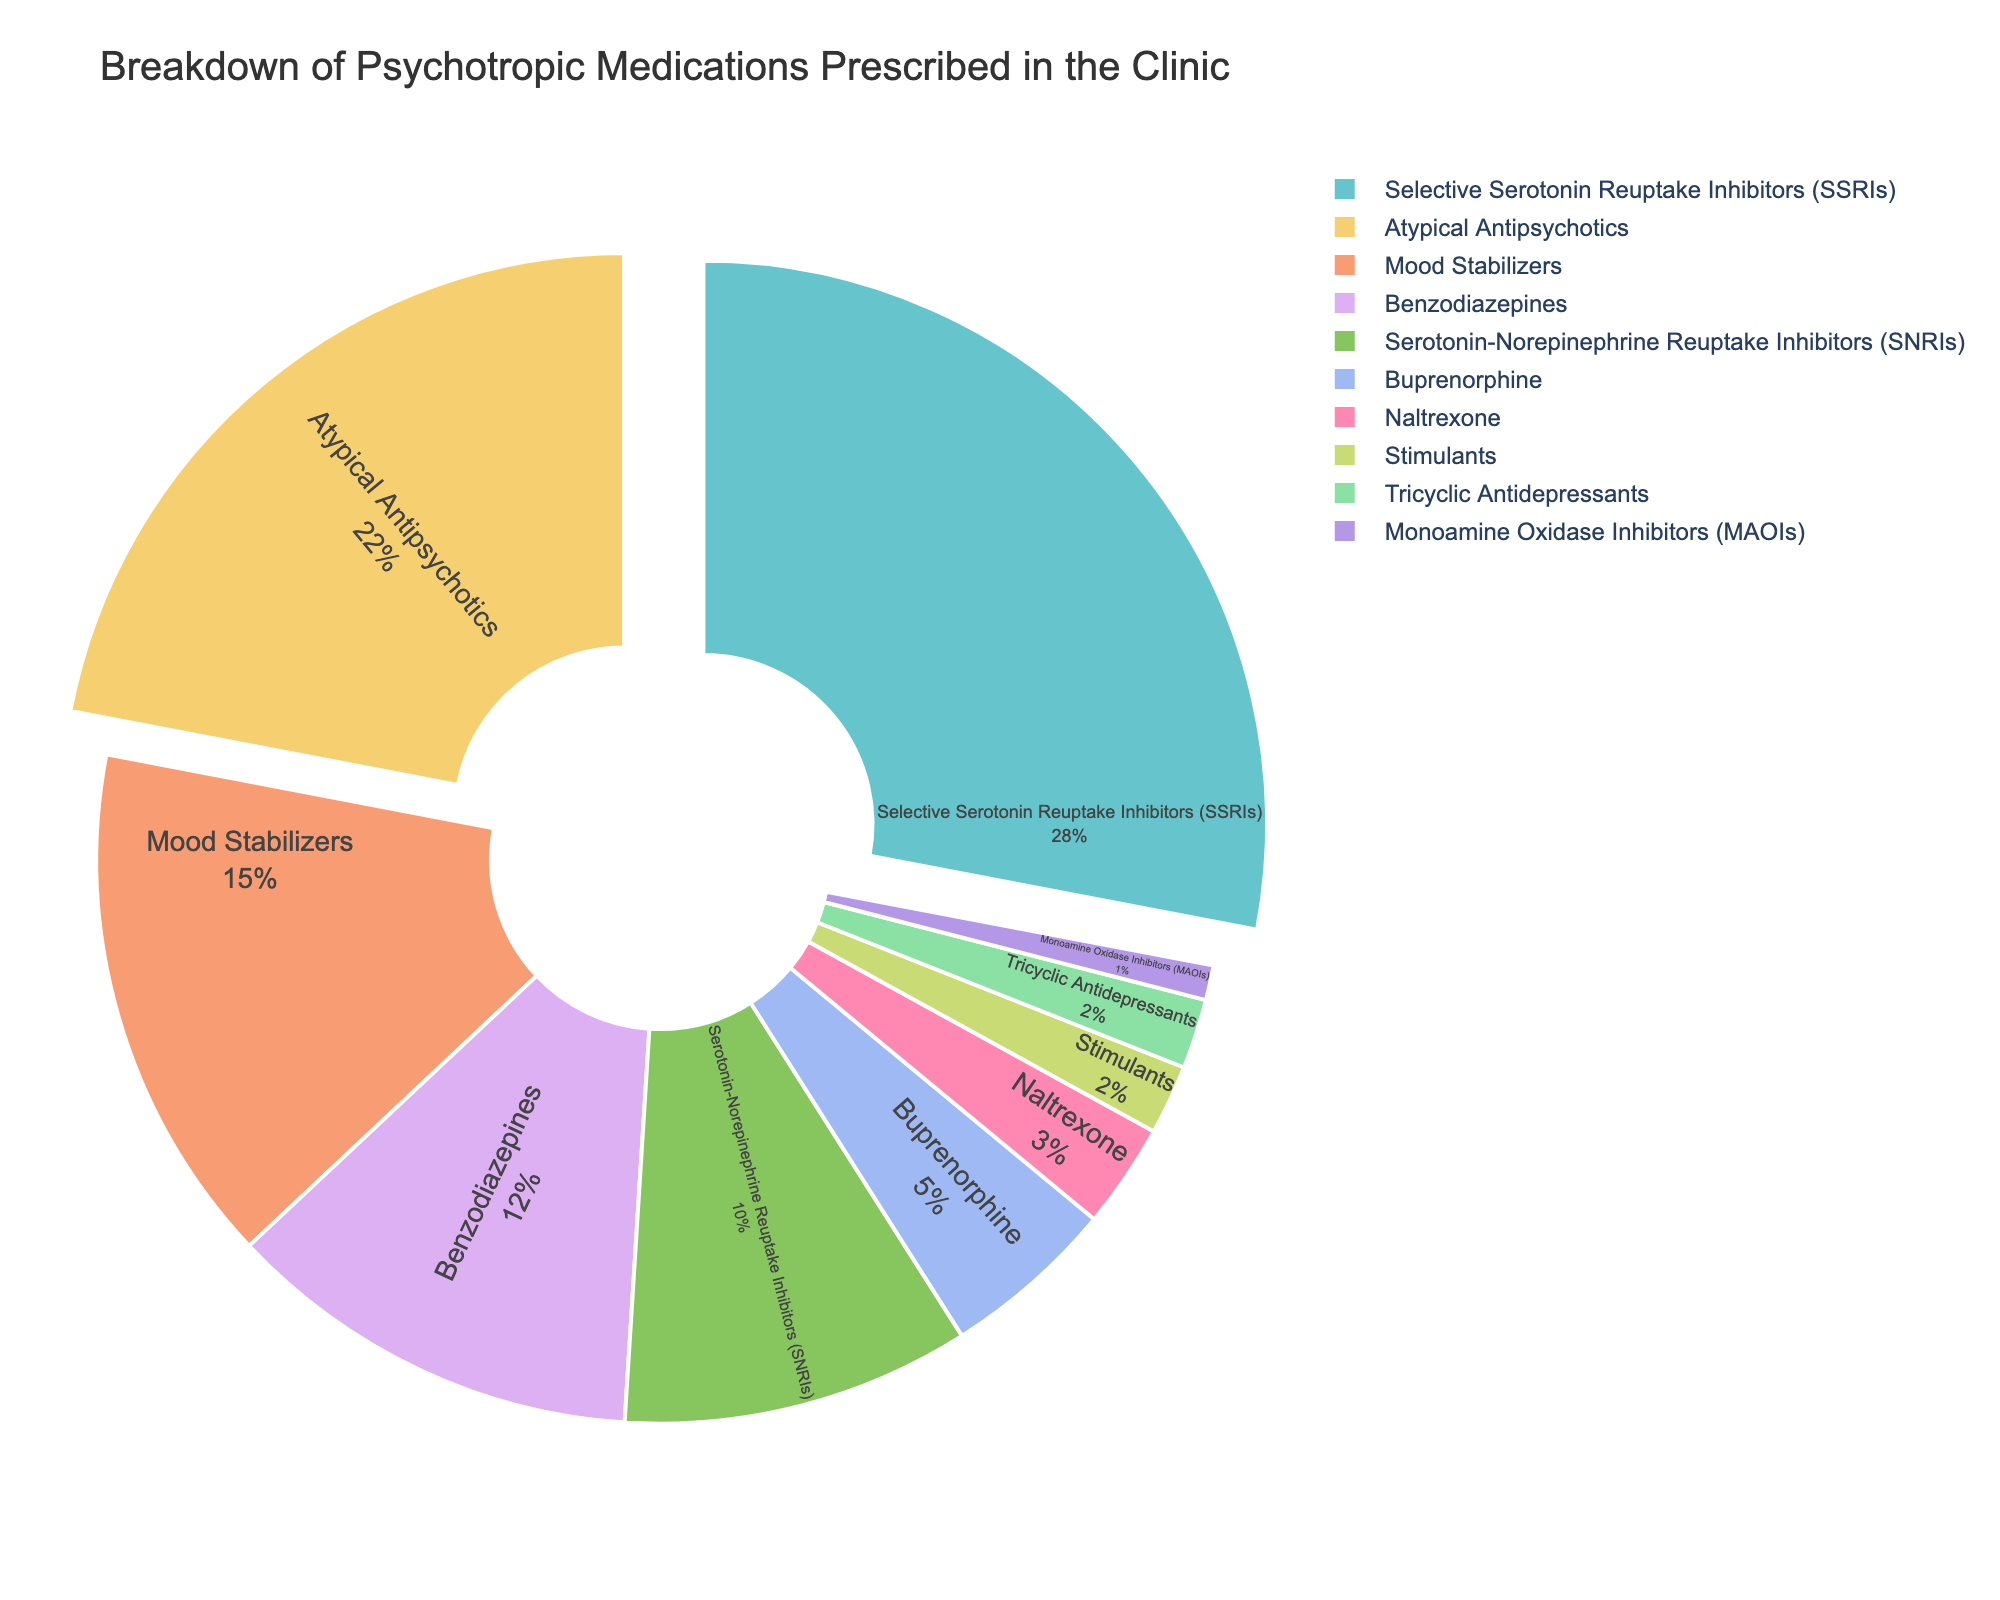What percentage of medications prescribed are SSRIs? The pie chart shows the SSRIs segment, labeled with their percentage. Look at the label inside the SSRIs segment to find the percentage.
Answer: 28% Which type of psychotropic medication is prescribed the most? Identify the largest segment in the pie chart and read the label inside it to determine the most frequently prescribed medication.
Answer: Selective Serotonin Reuptake Inhibitors (SSRIs) How much more frequent are SSRIs prescribed compared to Benzodiazepines? First, find the percentages for SSRIs (28%) and Benzodiazepines (12%) in the pie chart. Then, subtract the percentage of Benzodiazepines from the percentage of SSRIs. 28% - 12%
Answer: 16% Which two types of medications make up half of the prescriptions? To find this, identify the two largest segments in the pie chart and check if their combined percentages equal 50%. SSRIs (28%) + Atypical Antipsychotics (22%) = 50%
Answer: SSRIs and Atypical Antipsychotics What is the second most commonly prescribed category of medication? Examine the pie chart to identify the second largest segment by size and read its label.
Answer: Atypical Antipsychotics How many types of medications have a prescription percentage below 10%? Locate all the segments in the pie chart with percentages less than 10% and count them.
Answer: 5 What is the combined percentage of Mood Stabilizers and SNRIs? Add the percentage of Mood Stabilizers (15%) to that of SNRIs (10%). 15% + 10%
Answer: 25% Are Tricyclic Antidepressants or Stimulants prescribed more frequently? Compare the percentages in the pie chart for Tricyclic Antidepressants and Stimulants. Tricyclic Antidepressants: 2%, Stimulants: 2%. Based on this pie chart, they are equal.
Answer: Equal Which medication category takes up the smallest portion of the pie chart? Look for the smallest segment in the pie chart and read its label to identify the medication.
Answer: Monoamine Oxidase Inhibitors (MAOIs) How does the prescription rate of Buprenorphine compare to that of Naltrexone? Check the pie chart to find the percentages for Buprenorphine (5%) and Naltrexone (3%), then compare the values.
Answer: Buprenorphine > Naltrexone 